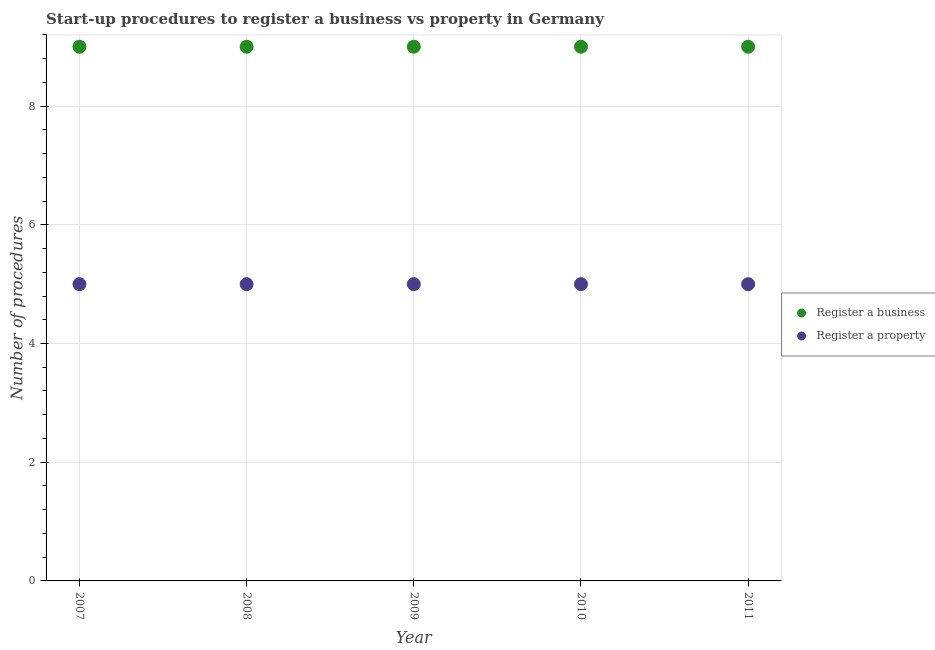How many different coloured dotlines are there?
Your response must be concise. 2. What is the number of procedures to register a business in 2008?
Your response must be concise. 9. Across all years, what is the maximum number of procedures to register a business?
Keep it short and to the point. 9. Across all years, what is the minimum number of procedures to register a property?
Offer a very short reply. 5. In which year was the number of procedures to register a business maximum?
Ensure brevity in your answer.  2007. In which year was the number of procedures to register a property minimum?
Your response must be concise. 2007. What is the total number of procedures to register a property in the graph?
Ensure brevity in your answer.  25. What is the difference between the number of procedures to register a business in 2007 and the number of procedures to register a property in 2010?
Your answer should be very brief. 4. In the year 2011, what is the difference between the number of procedures to register a property and number of procedures to register a business?
Make the answer very short. -4. In how many years, is the number of procedures to register a business greater than 0.4?
Your answer should be compact. 5. Is the difference between the number of procedures to register a property in 2009 and 2010 greater than the difference between the number of procedures to register a business in 2009 and 2010?
Give a very brief answer. No. Does the number of procedures to register a business monotonically increase over the years?
Your response must be concise. No. Is the number of procedures to register a property strictly greater than the number of procedures to register a business over the years?
Offer a terse response. No. How many dotlines are there?
Ensure brevity in your answer.  2. How many years are there in the graph?
Make the answer very short. 5. What is the difference between two consecutive major ticks on the Y-axis?
Keep it short and to the point. 2. Are the values on the major ticks of Y-axis written in scientific E-notation?
Provide a short and direct response. No. Where does the legend appear in the graph?
Your answer should be very brief. Center right. What is the title of the graph?
Offer a terse response. Start-up procedures to register a business vs property in Germany. What is the label or title of the Y-axis?
Your answer should be compact. Number of procedures. What is the Number of procedures in Register a property in 2007?
Ensure brevity in your answer.  5. What is the Number of procedures of Register a property in 2008?
Provide a succinct answer. 5. What is the Number of procedures in Register a property in 2009?
Offer a very short reply. 5. What is the Number of procedures of Register a business in 2011?
Give a very brief answer. 9. Across all years, what is the maximum Number of procedures in Register a business?
Give a very brief answer. 9. Across all years, what is the minimum Number of procedures in Register a business?
Keep it short and to the point. 9. Across all years, what is the minimum Number of procedures of Register a property?
Your answer should be compact. 5. What is the total Number of procedures of Register a business in the graph?
Give a very brief answer. 45. What is the total Number of procedures of Register a property in the graph?
Provide a succinct answer. 25. What is the difference between the Number of procedures of Register a property in 2007 and that in 2008?
Keep it short and to the point. 0. What is the difference between the Number of procedures in Register a business in 2007 and that in 2009?
Offer a terse response. 0. What is the difference between the Number of procedures of Register a property in 2007 and that in 2009?
Provide a succinct answer. 0. What is the difference between the Number of procedures in Register a business in 2007 and that in 2010?
Your response must be concise. 0. What is the difference between the Number of procedures of Register a property in 2007 and that in 2011?
Offer a very short reply. 0. What is the difference between the Number of procedures of Register a business in 2008 and that in 2009?
Ensure brevity in your answer.  0. What is the difference between the Number of procedures of Register a property in 2008 and that in 2009?
Offer a very short reply. 0. What is the difference between the Number of procedures in Register a business in 2008 and that in 2011?
Ensure brevity in your answer.  0. What is the difference between the Number of procedures in Register a property in 2008 and that in 2011?
Your response must be concise. 0. What is the difference between the Number of procedures of Register a business in 2010 and that in 2011?
Keep it short and to the point. 0. What is the difference between the Number of procedures of Register a business in 2007 and the Number of procedures of Register a property in 2008?
Offer a very short reply. 4. What is the difference between the Number of procedures of Register a business in 2007 and the Number of procedures of Register a property in 2010?
Give a very brief answer. 4. What is the difference between the Number of procedures of Register a business in 2008 and the Number of procedures of Register a property in 2009?
Keep it short and to the point. 4. What is the difference between the Number of procedures in Register a business in 2008 and the Number of procedures in Register a property in 2010?
Keep it short and to the point. 4. What is the difference between the Number of procedures of Register a business in 2008 and the Number of procedures of Register a property in 2011?
Your answer should be compact. 4. What is the difference between the Number of procedures of Register a business in 2009 and the Number of procedures of Register a property in 2010?
Make the answer very short. 4. What is the difference between the Number of procedures of Register a business in 2010 and the Number of procedures of Register a property in 2011?
Ensure brevity in your answer.  4. What is the average Number of procedures of Register a business per year?
Provide a succinct answer. 9. What is the average Number of procedures in Register a property per year?
Offer a very short reply. 5. In the year 2007, what is the difference between the Number of procedures in Register a business and Number of procedures in Register a property?
Provide a succinct answer. 4. In the year 2009, what is the difference between the Number of procedures of Register a business and Number of procedures of Register a property?
Your answer should be very brief. 4. In the year 2010, what is the difference between the Number of procedures of Register a business and Number of procedures of Register a property?
Your answer should be very brief. 4. In the year 2011, what is the difference between the Number of procedures in Register a business and Number of procedures in Register a property?
Your answer should be compact. 4. What is the ratio of the Number of procedures in Register a property in 2007 to that in 2008?
Your answer should be compact. 1. What is the ratio of the Number of procedures of Register a business in 2007 to that in 2010?
Your response must be concise. 1. What is the ratio of the Number of procedures in Register a property in 2007 to that in 2011?
Keep it short and to the point. 1. What is the ratio of the Number of procedures of Register a property in 2008 to that in 2009?
Provide a succinct answer. 1. What is the ratio of the Number of procedures in Register a business in 2008 to that in 2011?
Provide a succinct answer. 1. What is the ratio of the Number of procedures of Register a property in 2008 to that in 2011?
Your answer should be very brief. 1. What is the ratio of the Number of procedures in Register a business in 2009 to that in 2010?
Provide a short and direct response. 1. What is the ratio of the Number of procedures in Register a business in 2010 to that in 2011?
Your response must be concise. 1. What is the ratio of the Number of procedures in Register a property in 2010 to that in 2011?
Your answer should be compact. 1. What is the difference between the highest and the lowest Number of procedures of Register a business?
Offer a terse response. 0. What is the difference between the highest and the lowest Number of procedures in Register a property?
Your answer should be very brief. 0. 